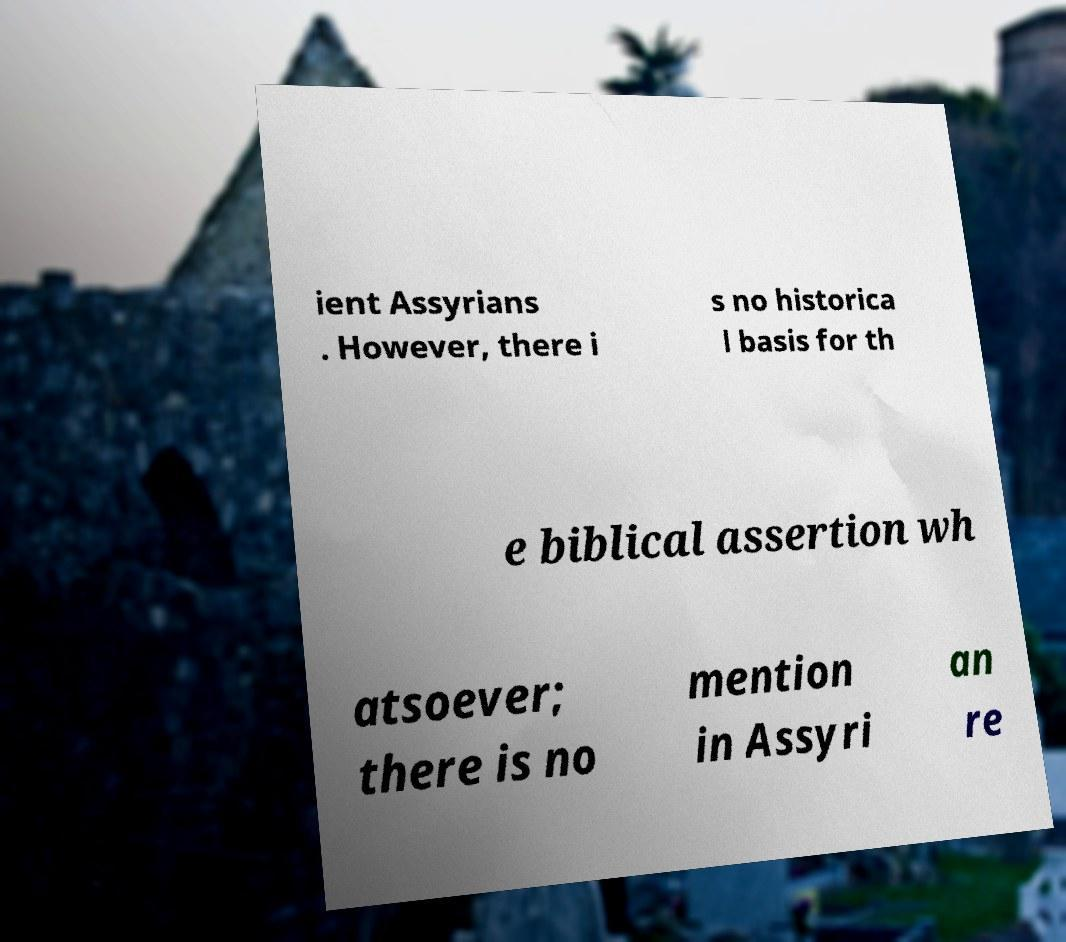Can you accurately transcribe the text from the provided image for me? ient Assyrians . However, there i s no historica l basis for th e biblical assertion wh atsoever; there is no mention in Assyri an re 